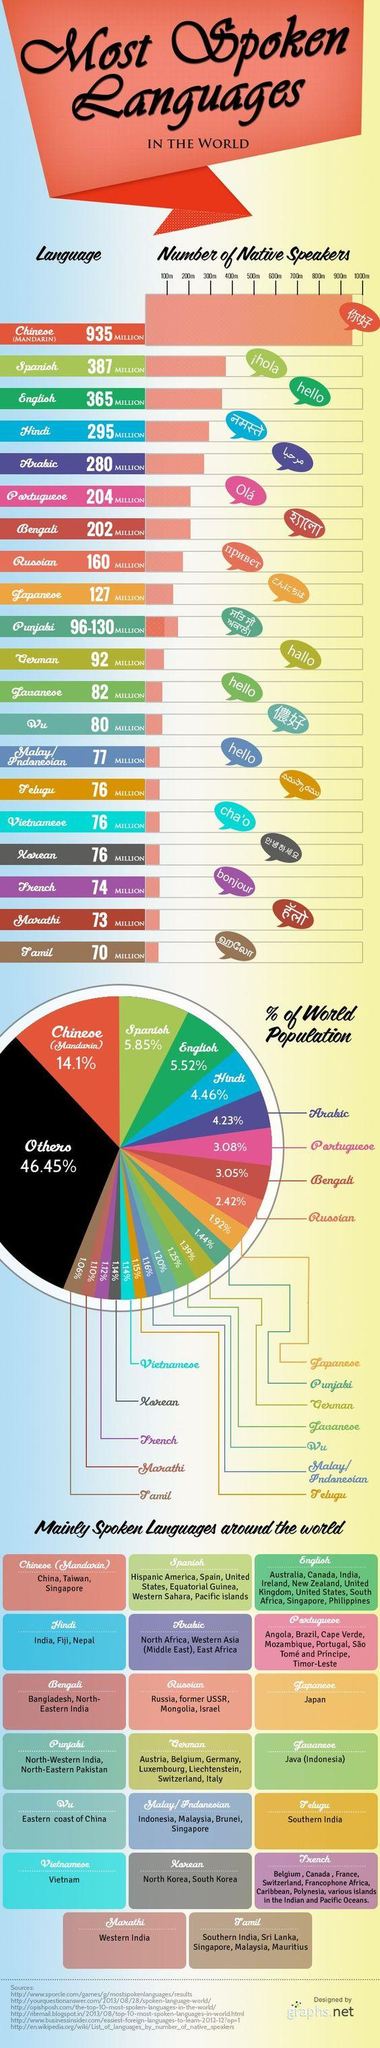Point out several critical features in this image. According to data, approximately 8.69% of the world's population speaks either Hindi or Arabic. Among these languages, how many are spoken in India? Seven of them are spoken in India. Bengali is the most spoken language after Arabic and Portuguese. According to the infographic, Fiji and Nepal are countries with Hindi speaking populations other than India. Hindi is the fourth most widely spoken language in the world. 